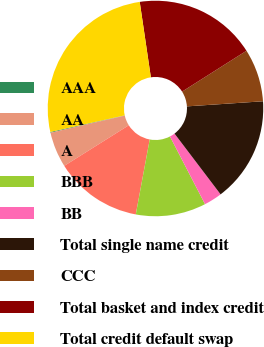<chart> <loc_0><loc_0><loc_500><loc_500><pie_chart><fcel>AAA<fcel>AA<fcel>A<fcel>BBB<fcel>BB<fcel>Total single name credit<fcel>CCC<fcel>Total basket and index credit<fcel>Total credit default swap<nl><fcel>0.12%<fcel>5.32%<fcel>13.14%<fcel>10.53%<fcel>2.72%<fcel>15.74%<fcel>7.93%<fcel>18.34%<fcel>26.16%<nl></chart> 